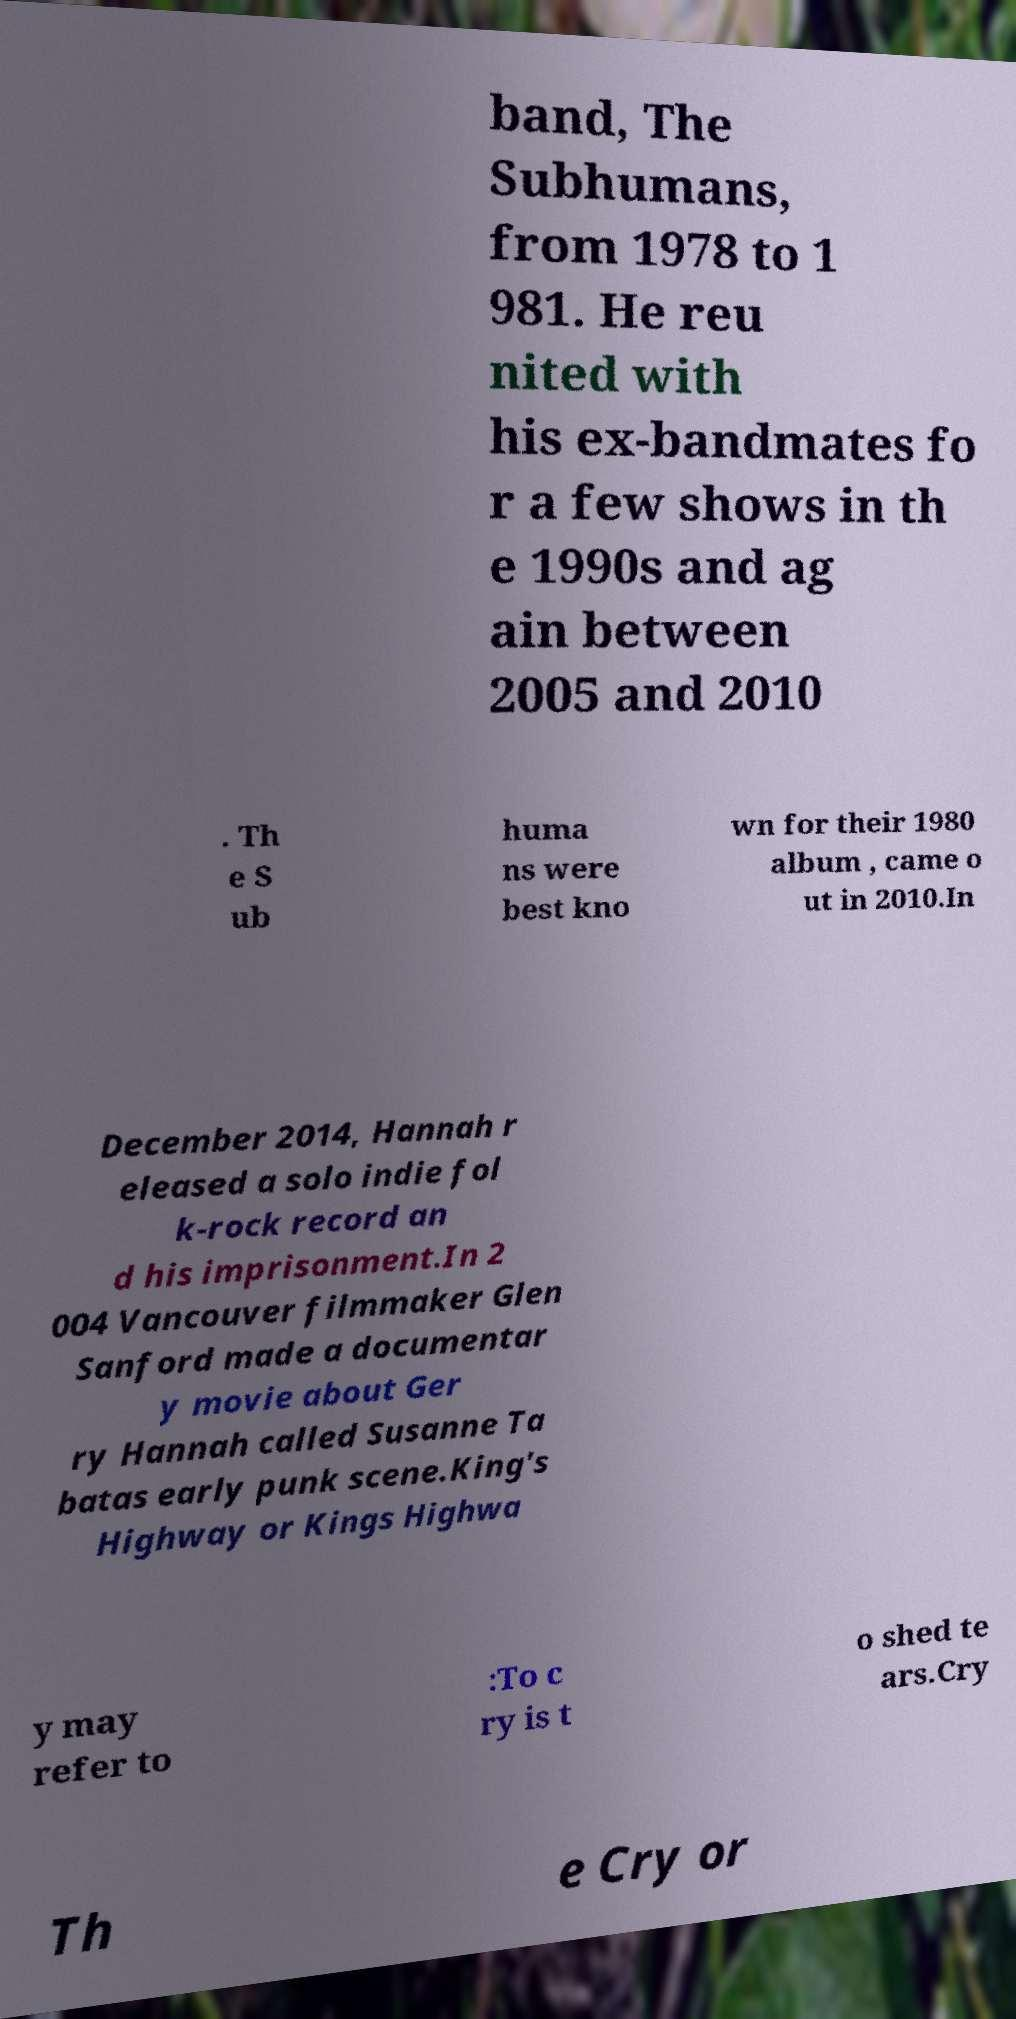Could you extract and type out the text from this image? band, The Subhumans, from 1978 to 1 981. He reu nited with his ex-bandmates fo r a few shows in th e 1990s and ag ain between 2005 and 2010 . Th e S ub huma ns were best kno wn for their 1980 album , came o ut in 2010.In December 2014, Hannah r eleased a solo indie fol k-rock record an d his imprisonment.In 2 004 Vancouver filmmaker Glen Sanford made a documentar y movie about Ger ry Hannah called Susanne Ta batas early punk scene.King's Highway or Kings Highwa y may refer to :To c ry is t o shed te ars.Cry Th e Cry or 